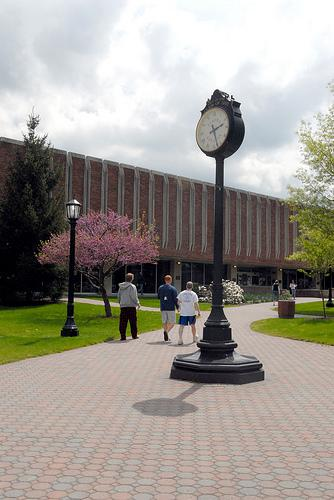Question: what structure is to the left of the clock?
Choices:
A. A bed.
B. A counter.
C. A garden bed.
D. Building.
Answer with the letter. Answer: D Question: how many clocks are in the photo?
Choices:
A. One.
B. Eight.
C. Three.
D. Two.
Answer with the letter. Answer: A Question: where is this taking place?
Choices:
A. In the street.
B. On a bridge.
C. On a brick walkway.
D. At the beach.
Answer with the letter. Answer: C Question: when is this taking place?
Choices:
A. Dusk.
B. Dawn.
C. Daylight.
D. Night time.
Answer with the letter. Answer: C 